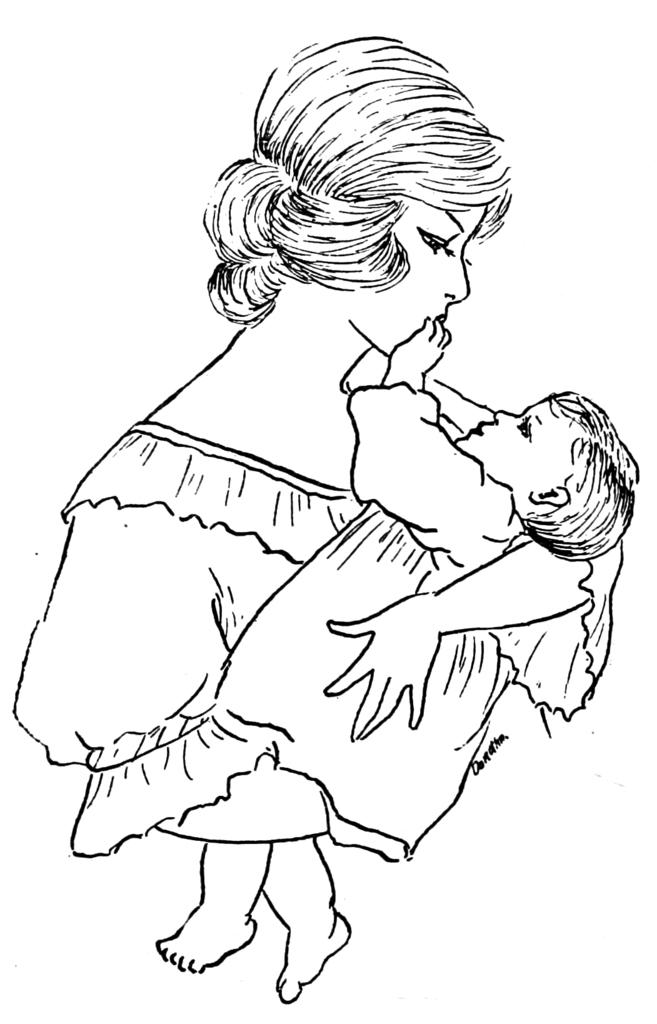What subjects are depicted in the drawing in the image? There is a drawing of a woman and a baby in the image. What type of loaf is being held by the woman in the drawing? There is no loaf present in the drawing; it only depicts a woman and a baby. 